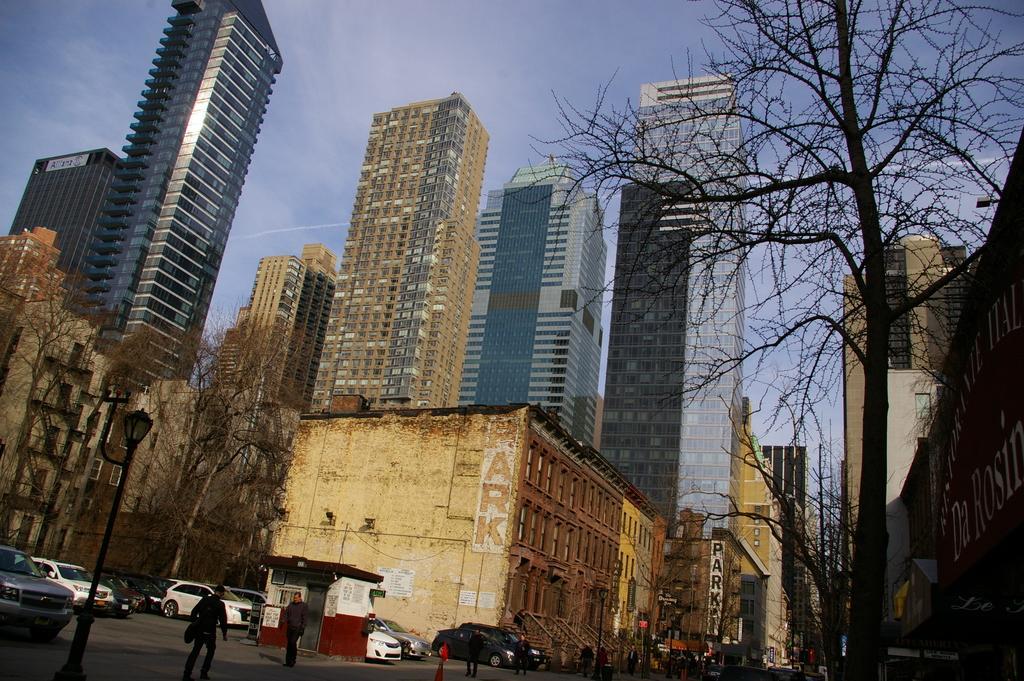In one or two sentences, can you explain what this image depicts? In this image, we can see vehicles, people, poles, name boards and sign boards and we can see a booth on the road. In the background, there are trees and buildings. At the top, there is sky. 